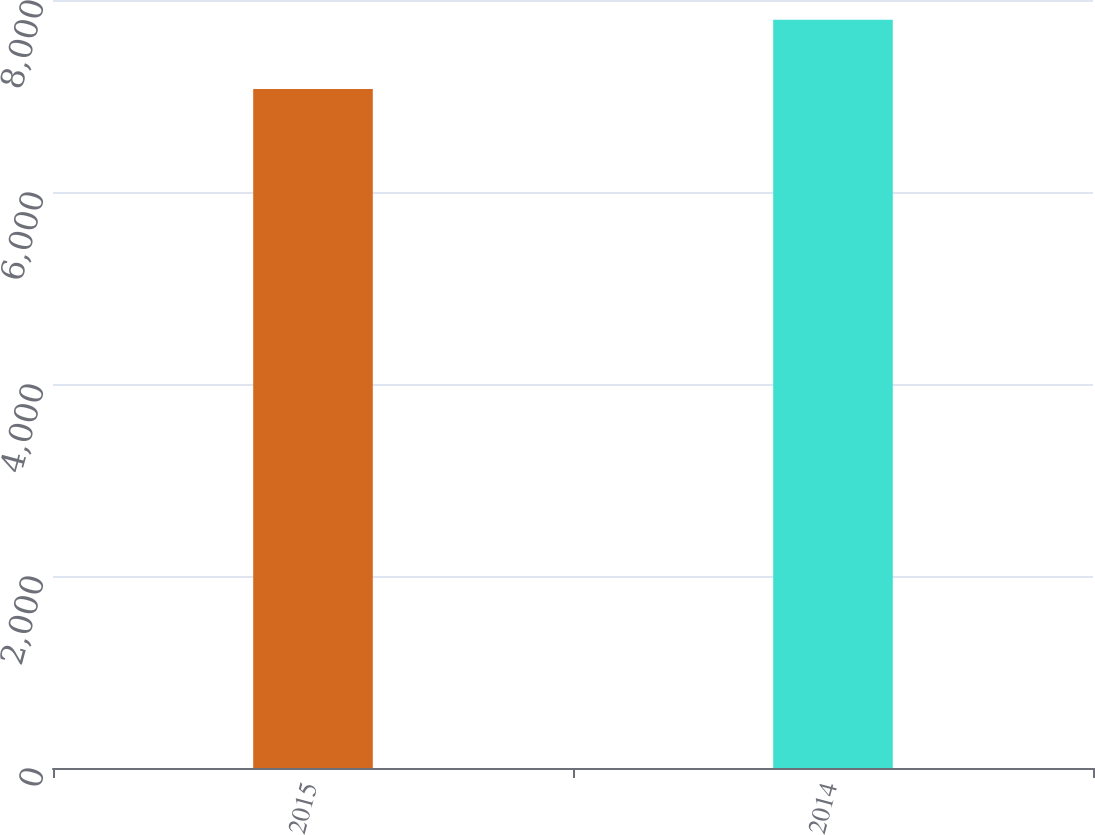<chart> <loc_0><loc_0><loc_500><loc_500><bar_chart><fcel>2015<fcel>2014<nl><fcel>7072<fcel>7793<nl></chart> 